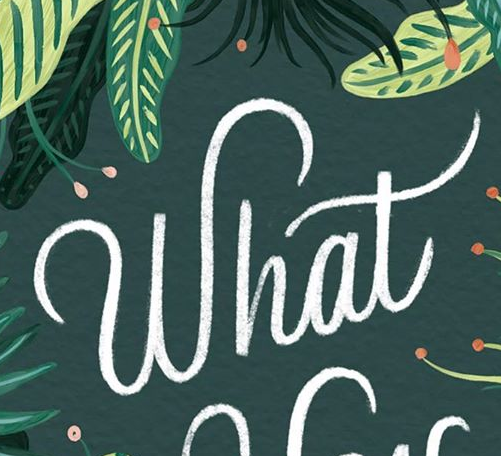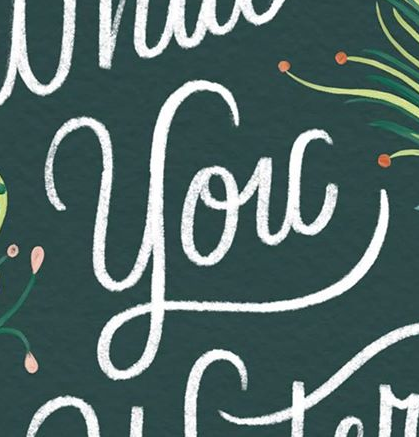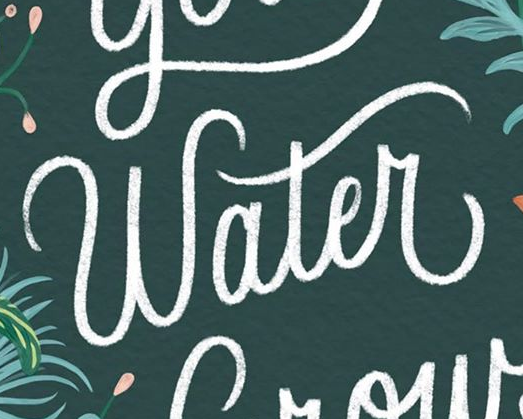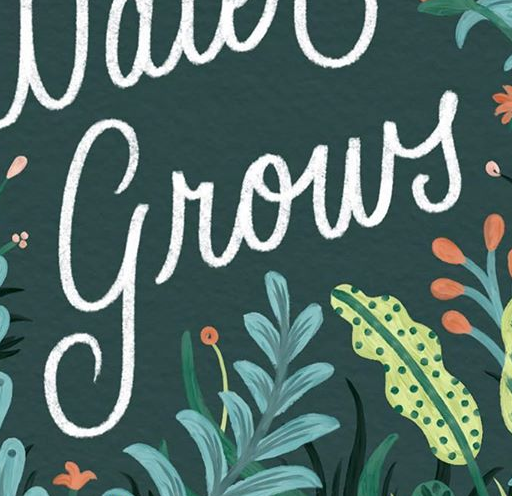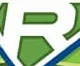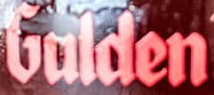Read the text from these images in sequence, separated by a semicolon. What; You; Water; grows; R; Gulden 